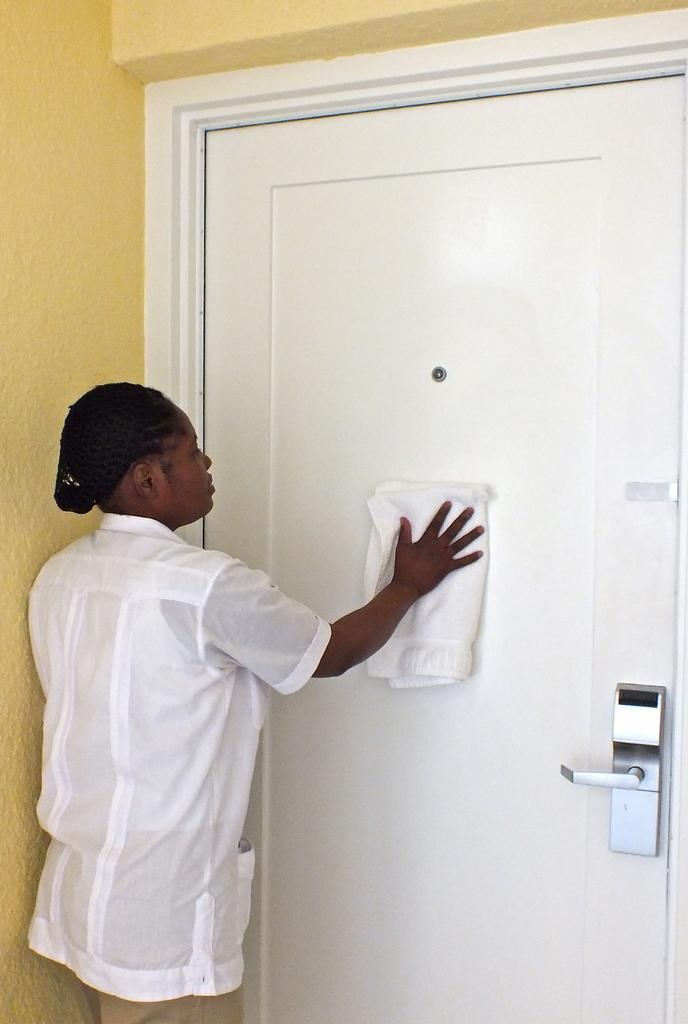Who is in the image? There is a woman in the image. What is the woman wearing? The woman is wearing a white shirt. What is the woman doing in front of the door? The woman is cleaning the white door with a cloth. What color is the wall above the door? The wall above the door is yellow. What type of credit does the woman have in her pocket in the image? There is no mention of credit or pockets in the image, so we cannot determine if the woman has any credit in her pocket. 